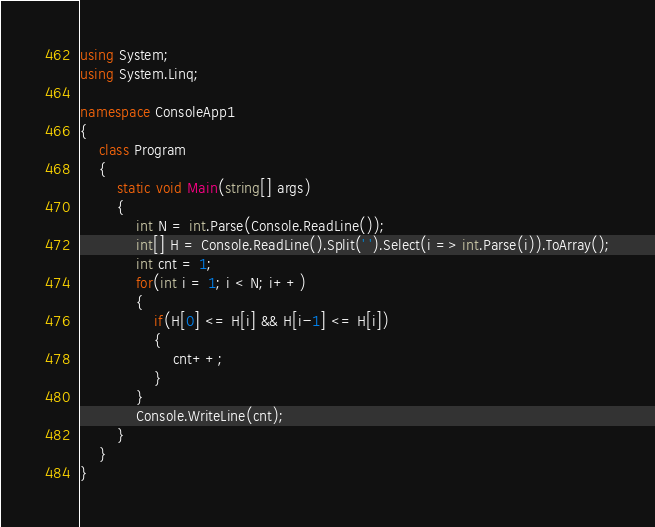Convert code to text. <code><loc_0><loc_0><loc_500><loc_500><_C#_>using System;
using System.Linq;

namespace ConsoleApp1
{
    class Program
    {
        static void Main(string[] args)
        {
            int N = int.Parse(Console.ReadLine());
            int[] H = Console.ReadLine().Split(' ').Select(i => int.Parse(i)).ToArray();
            int cnt = 1;
            for(int i = 1; i < N; i++)
            {
                if(H[0] <= H[i] && H[i-1] <= H[i])
                {
                    cnt++;
                }
            }
            Console.WriteLine(cnt);
        }
    }
}</code> 